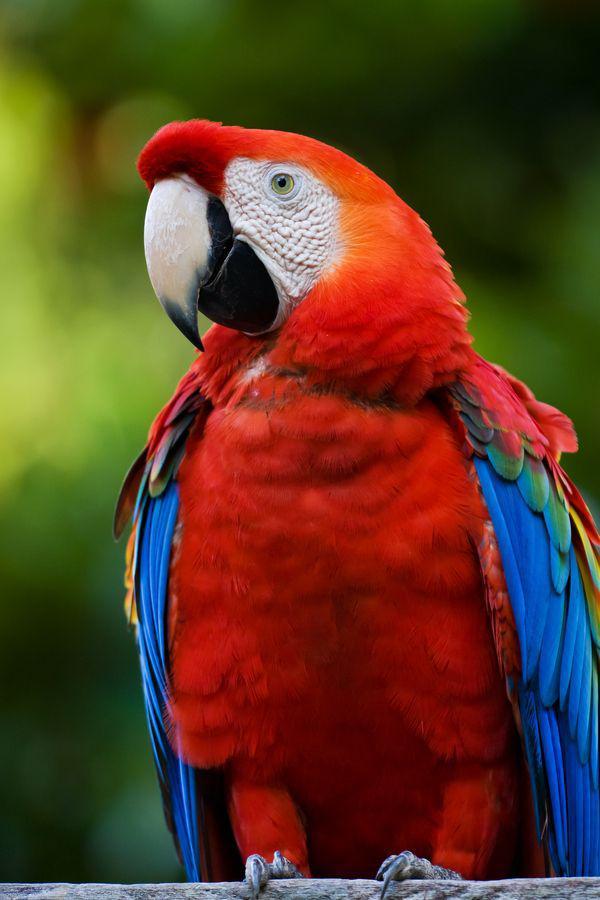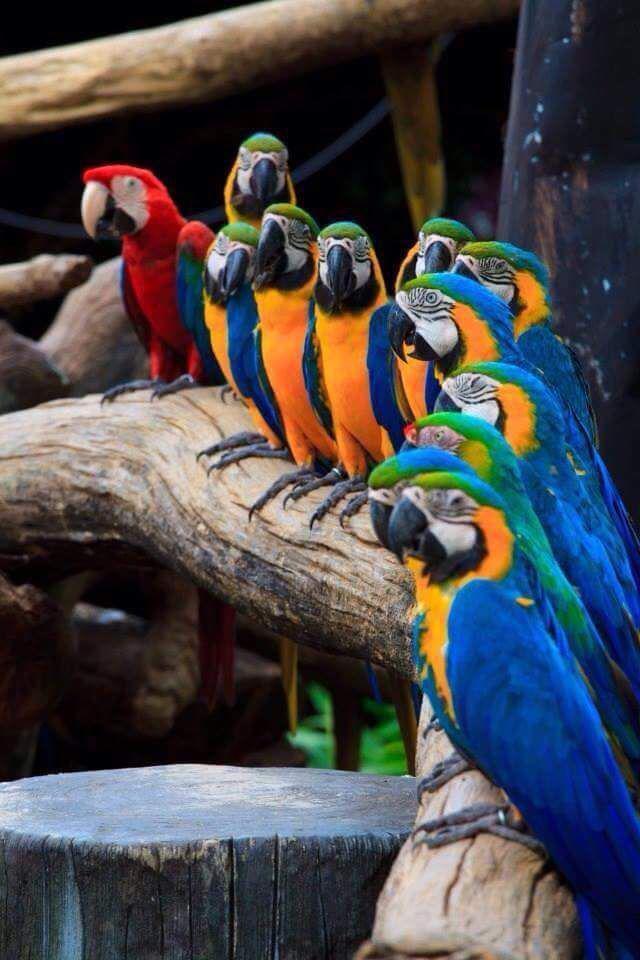The first image is the image on the left, the second image is the image on the right. Analyze the images presented: Is the assertion "The image to the right is a row of yellow fronted macaws with one red one at the left end." valid? Answer yes or no. Yes. 